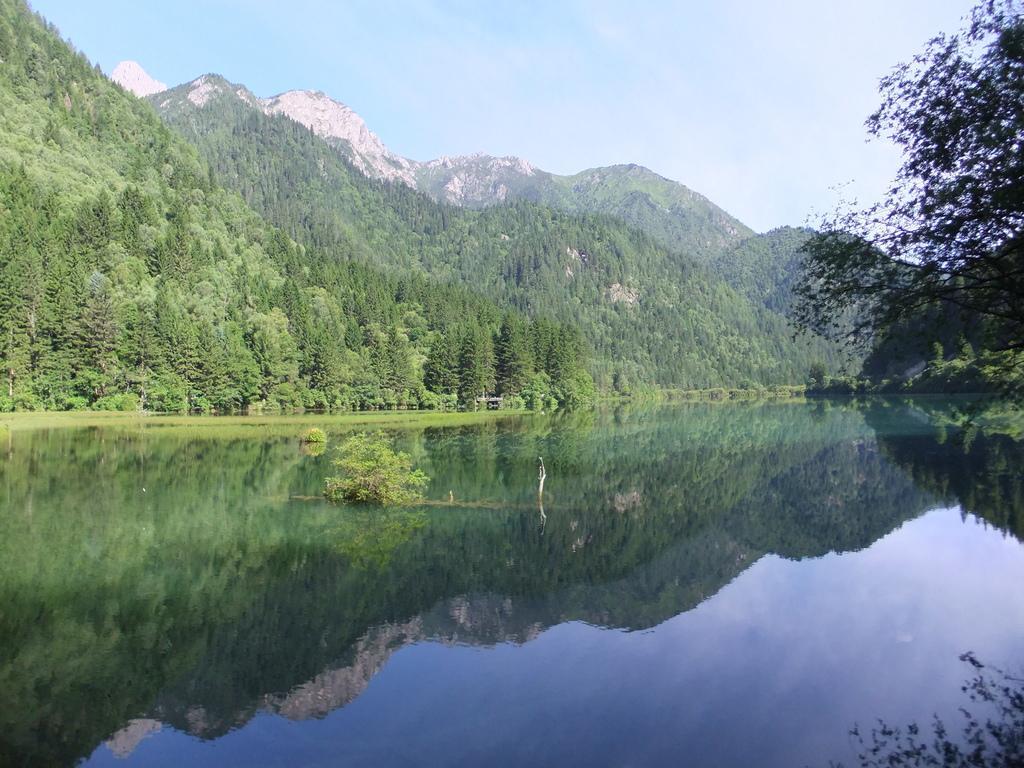In one or two sentences, can you explain what this image depicts? In this image in front there is water. There are plants. In the background of the image there are trees, mountains and sky. 